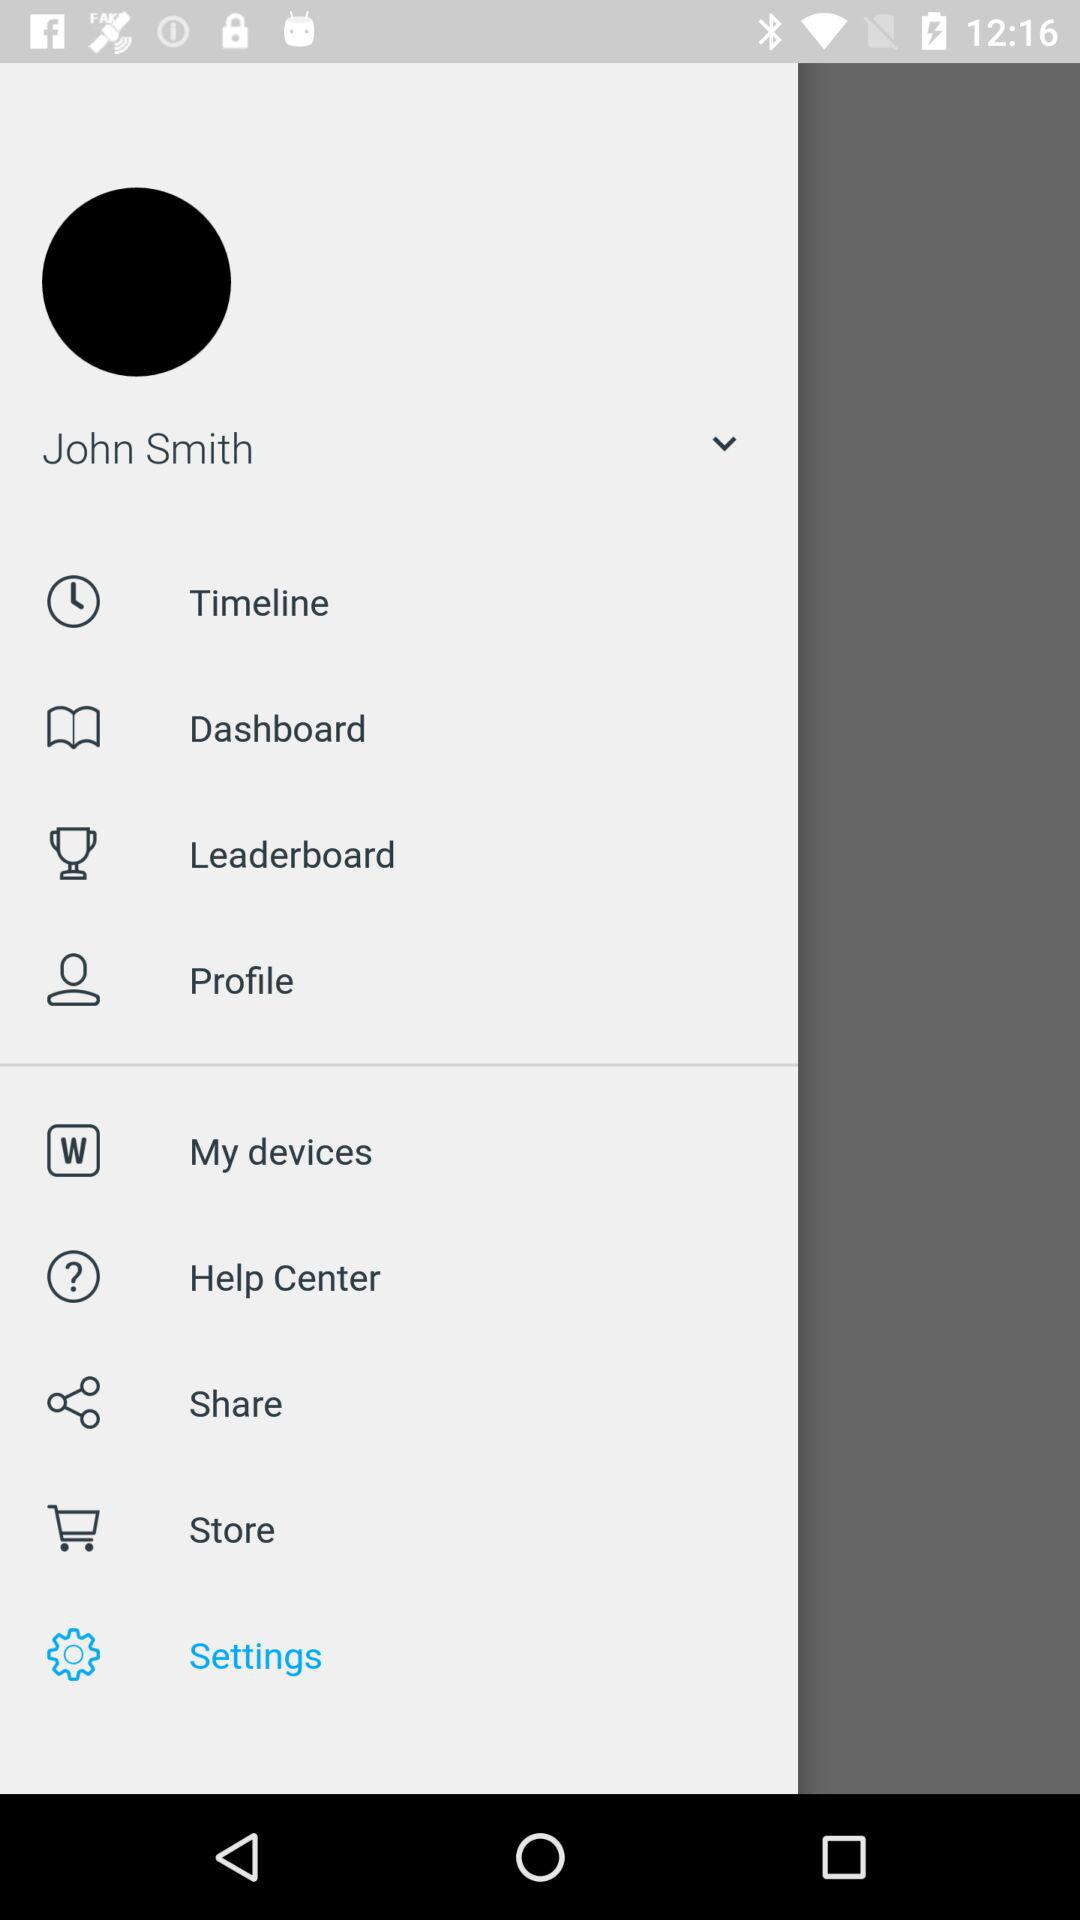What is the name of the user? The name of the user is John Smith. 